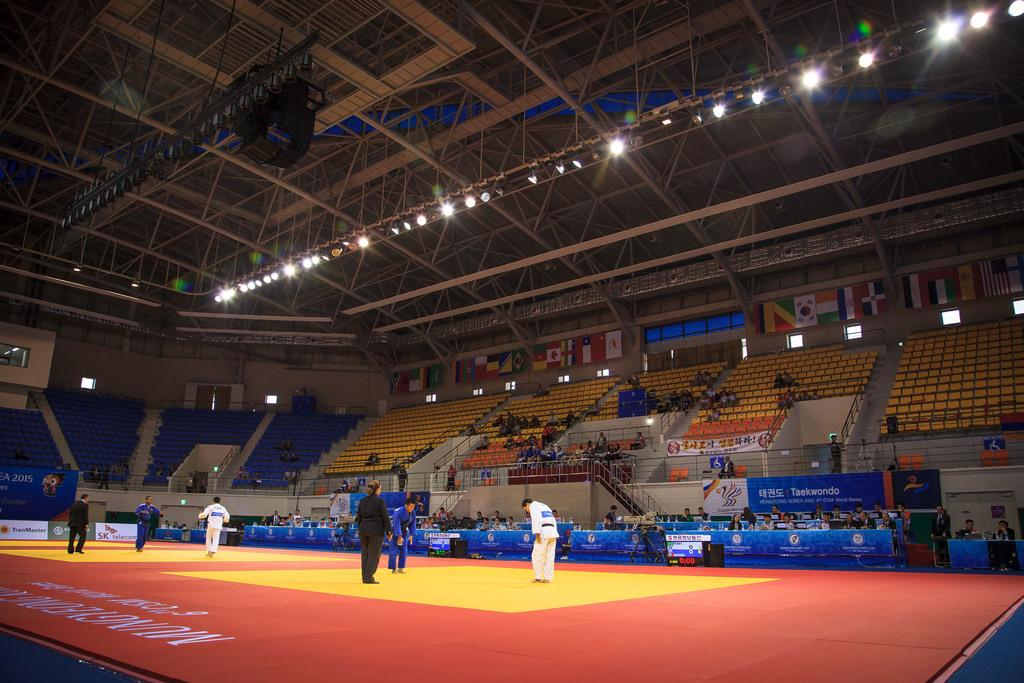<image>
Offer a succinct explanation of the picture presented. A martial arts match is underway in a stadium sponsored by SK telecom. 